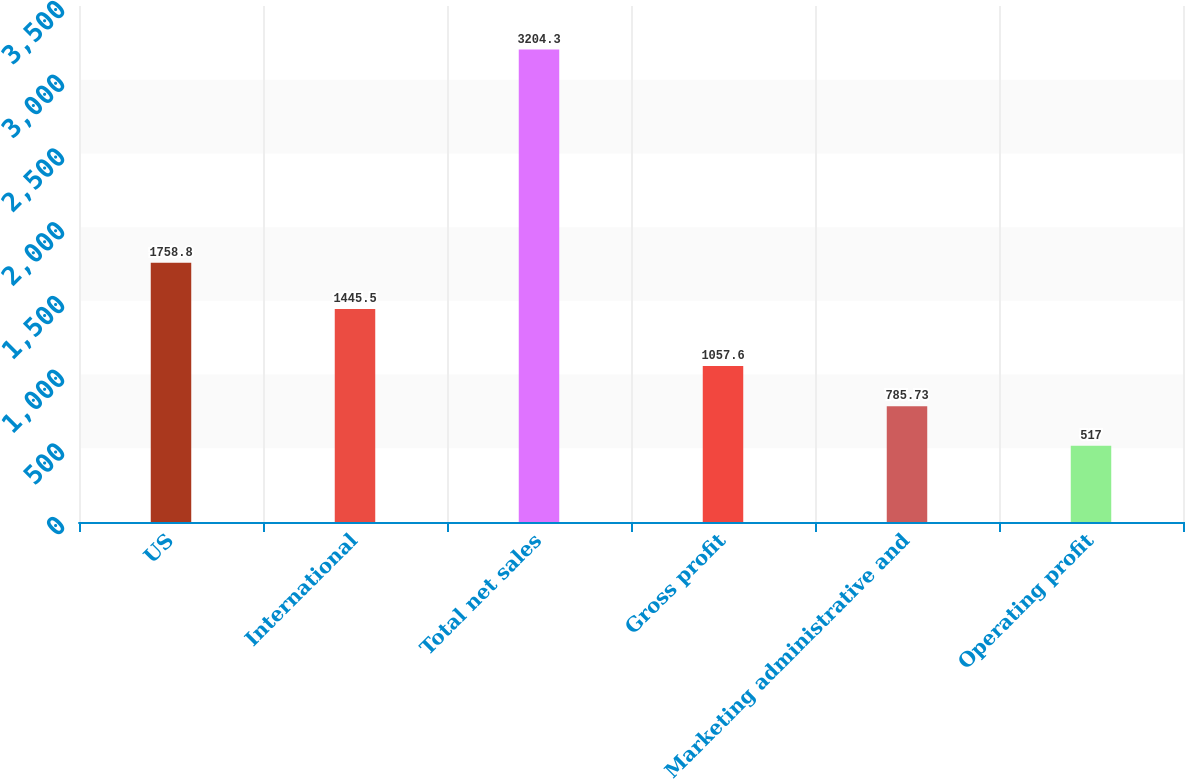Convert chart. <chart><loc_0><loc_0><loc_500><loc_500><bar_chart><fcel>US<fcel>International<fcel>Total net sales<fcel>Gross profit<fcel>Marketing administrative and<fcel>Operating profit<nl><fcel>1758.8<fcel>1445.5<fcel>3204.3<fcel>1057.6<fcel>785.73<fcel>517<nl></chart> 